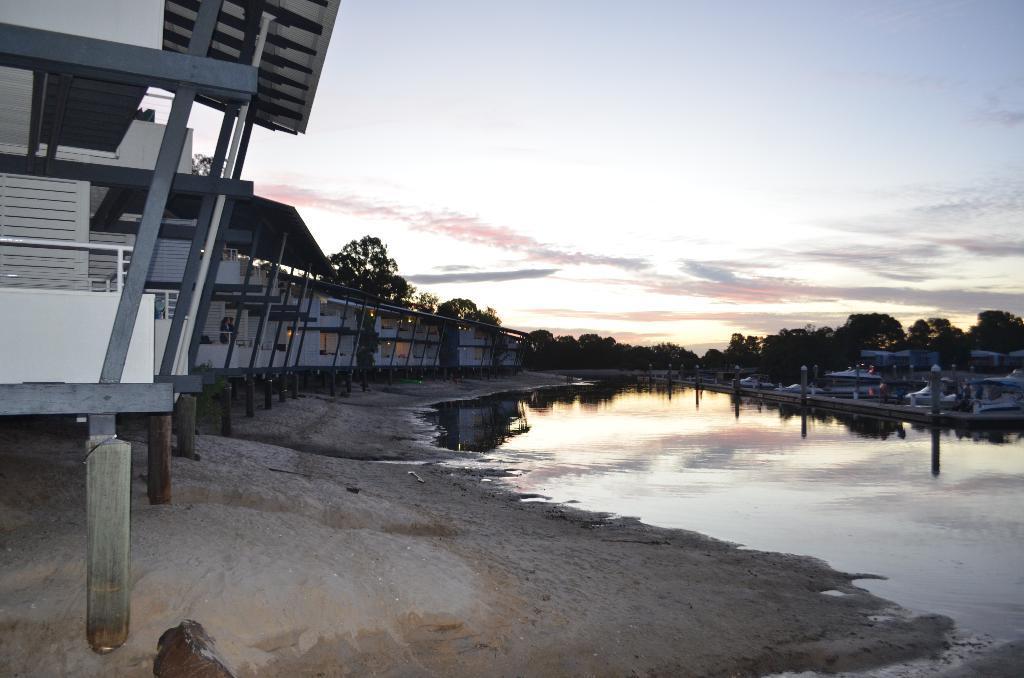In one or two sentences, can you explain what this image depicts? On the left side of the image there are some wooden houses, in front of the wooden houses there is a lake, on the other side of the lake there are boats and there are lamps on the wooden platform, in the background of the image there are trees, at the top of the image there are clouds in the sky. 